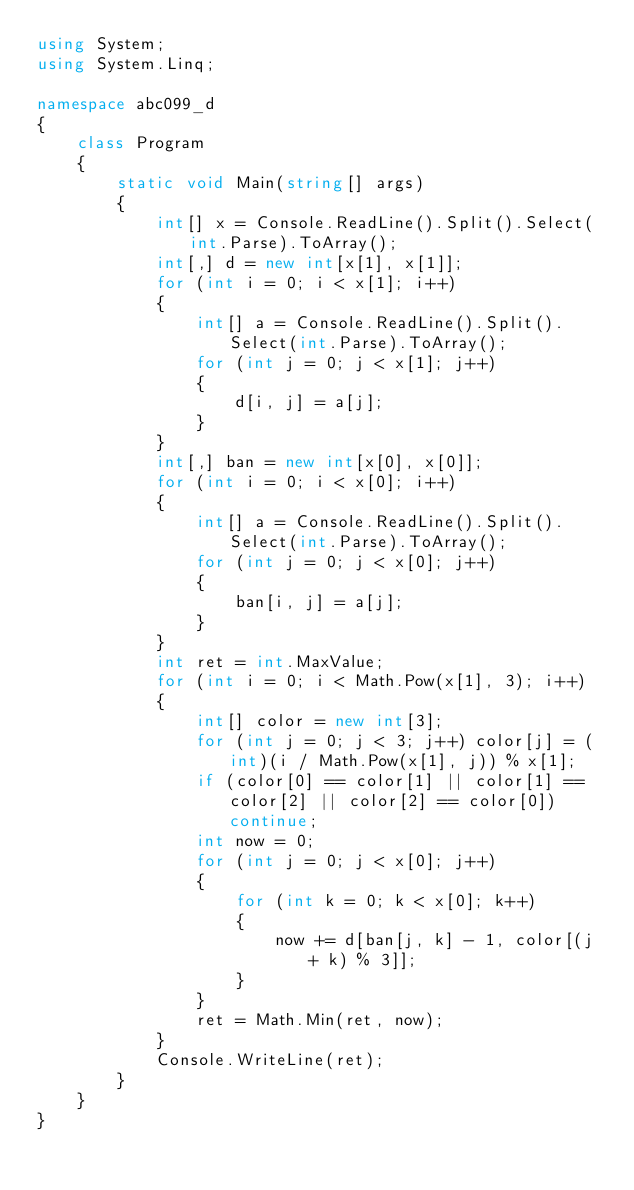Convert code to text. <code><loc_0><loc_0><loc_500><loc_500><_C#_>using System;
using System.Linq;

namespace abc099_d
{
    class Program
    {
        static void Main(string[] args)
        {
            int[] x = Console.ReadLine().Split().Select(int.Parse).ToArray();
            int[,] d = new int[x[1], x[1]];
            for (int i = 0; i < x[1]; i++)
            {
                int[] a = Console.ReadLine().Split().Select(int.Parse).ToArray();
                for (int j = 0; j < x[1]; j++)
                {
                    d[i, j] = a[j];
                }
            }
            int[,] ban = new int[x[0], x[0]];
            for (int i = 0; i < x[0]; i++)
            {
                int[] a = Console.ReadLine().Split().Select(int.Parse).ToArray();
                for (int j = 0; j < x[0]; j++)
                {
                    ban[i, j] = a[j];
                }
            }
            int ret = int.MaxValue;
            for (int i = 0; i < Math.Pow(x[1], 3); i++)
            {
                int[] color = new int[3];
                for (int j = 0; j < 3; j++) color[j] = (int)(i / Math.Pow(x[1], j)) % x[1];
                if (color[0] == color[1] || color[1] == color[2] || color[2] == color[0]) continue;
                int now = 0;
                for (int j = 0; j < x[0]; j++)
                {
                    for (int k = 0; k < x[0]; k++)
                    {
                        now += d[ban[j, k] - 1, color[(j + k) % 3]];
                    }
                }
                ret = Math.Min(ret, now);
            }
            Console.WriteLine(ret);
        }
    }
}</code> 